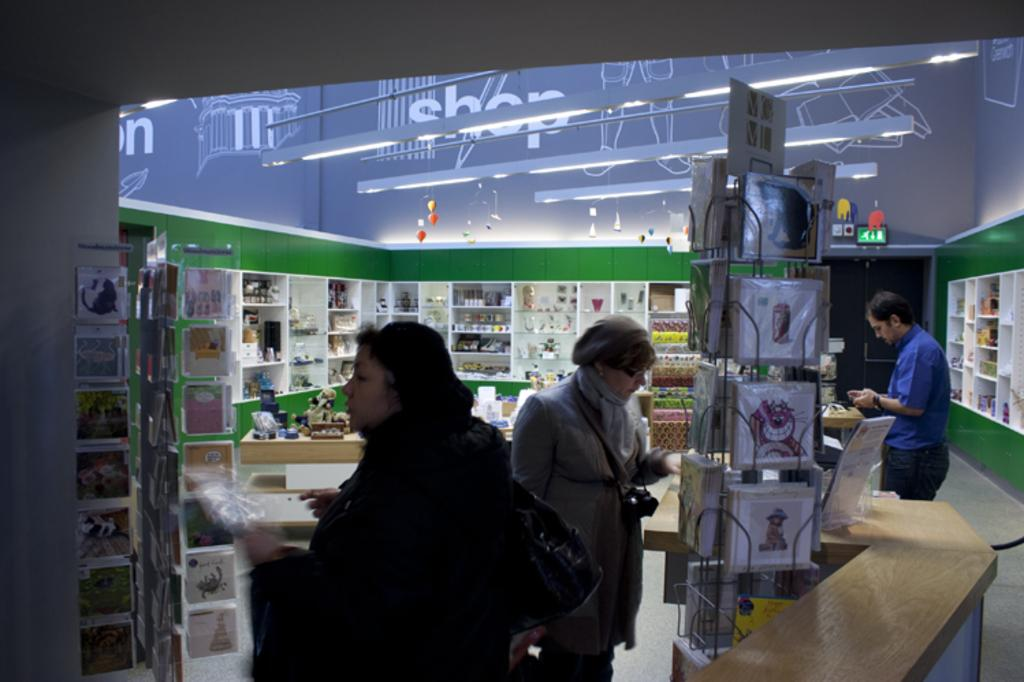<image>
Create a compact narrative representing the image presented. People are looking at greeting cards in a store that has the word shop up on the ceiling. 